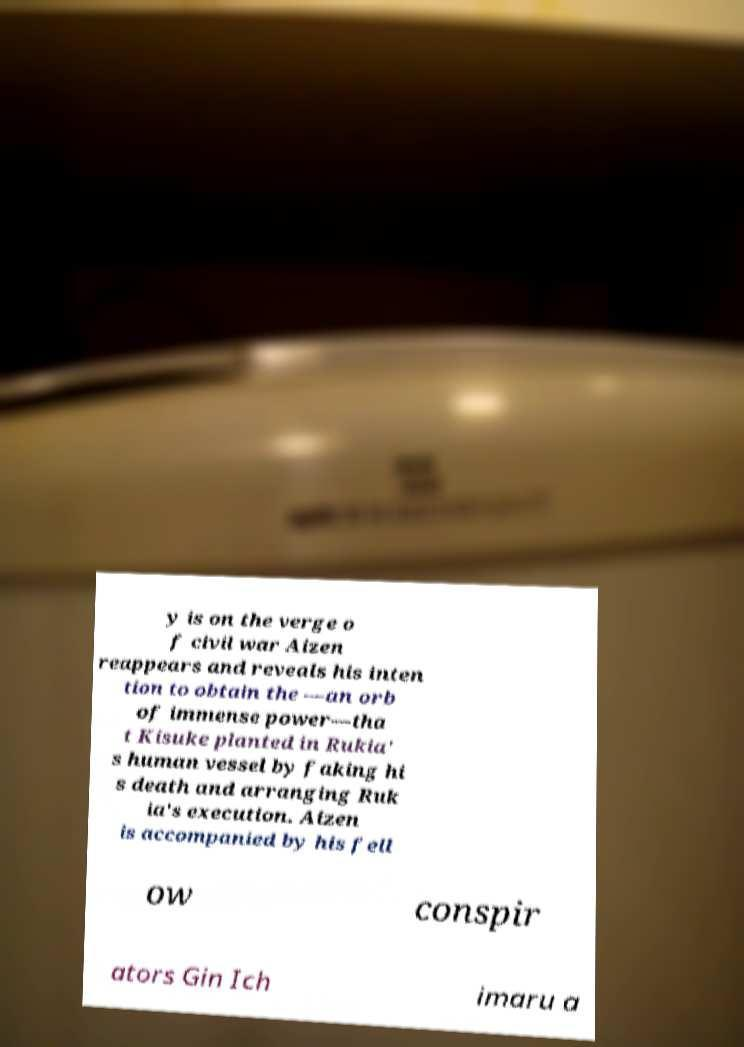Could you assist in decoding the text presented in this image and type it out clearly? y is on the verge o f civil war Aizen reappears and reveals his inten tion to obtain the —an orb of immense power—tha t Kisuke planted in Rukia' s human vessel by faking hi s death and arranging Ruk ia's execution. Aizen is accompanied by his fell ow conspir ators Gin Ich imaru a 